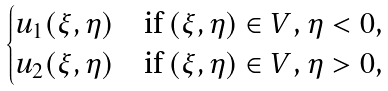Convert formula to latex. <formula><loc_0><loc_0><loc_500><loc_500>\begin{cases} u _ { 1 } ( \xi , \eta ) & \text {if $(\xi,\eta)\in V$, $\eta <0$,} \\ u _ { 2 } ( \xi , \eta ) & \text {if $(\xi,\eta)\in V$, $\eta >0$,} \end{cases}</formula> 